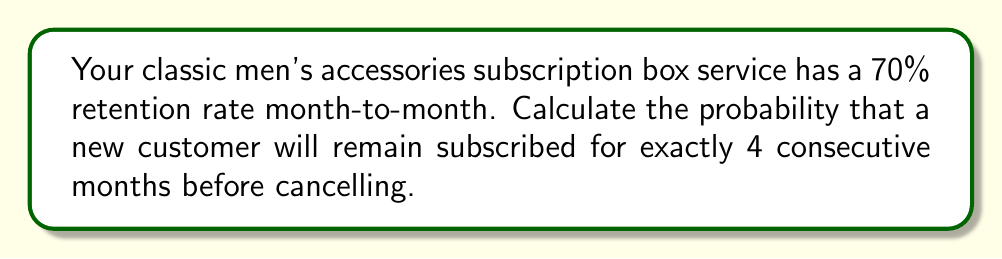Show me your answer to this math problem. Let's approach this step-by-step:

1) First, we need to understand what the question is asking. We want the probability of a customer staying subscribed for exactly 4 months, which means they must renew 3 times and then cancel.

2) The probability of renewing each month is 0.7 (70% retention rate).

3) The probability of cancelling is the complement of renewing, which is 1 - 0.7 = 0.3 (30% cancellation rate).

4) For the customer to stay exactly 4 months, we need:
   - Renewal after month 1 (probability 0.7)
   - Renewal after month 2 (probability 0.7)
   - Renewal after month 3 (probability 0.7)
   - Cancellation after month 4 (probability 0.3)

5) Since these are independent events, we multiply the probabilities:

   $$P(\text{exactly 4 months}) = 0.7 \times 0.7 \times 0.7 \times 0.3$$

6) Simplifying:

   $$P(\text{exactly 4 months}) = 0.7^3 \times 0.3$$

7) Calculating:

   $$P(\text{exactly 4 months}) = 0.343 \times 0.3 = 0.1029$$

8) Therefore, the probability is approximately 0.1029 or 10.29%.
Answer: 0.1029 